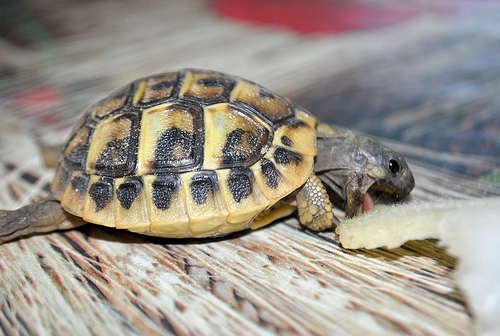<image>
Is the wood on the turtle? No. The wood is not positioned on the turtle. They may be near each other, but the wood is not supported by or resting on top of the turtle. 